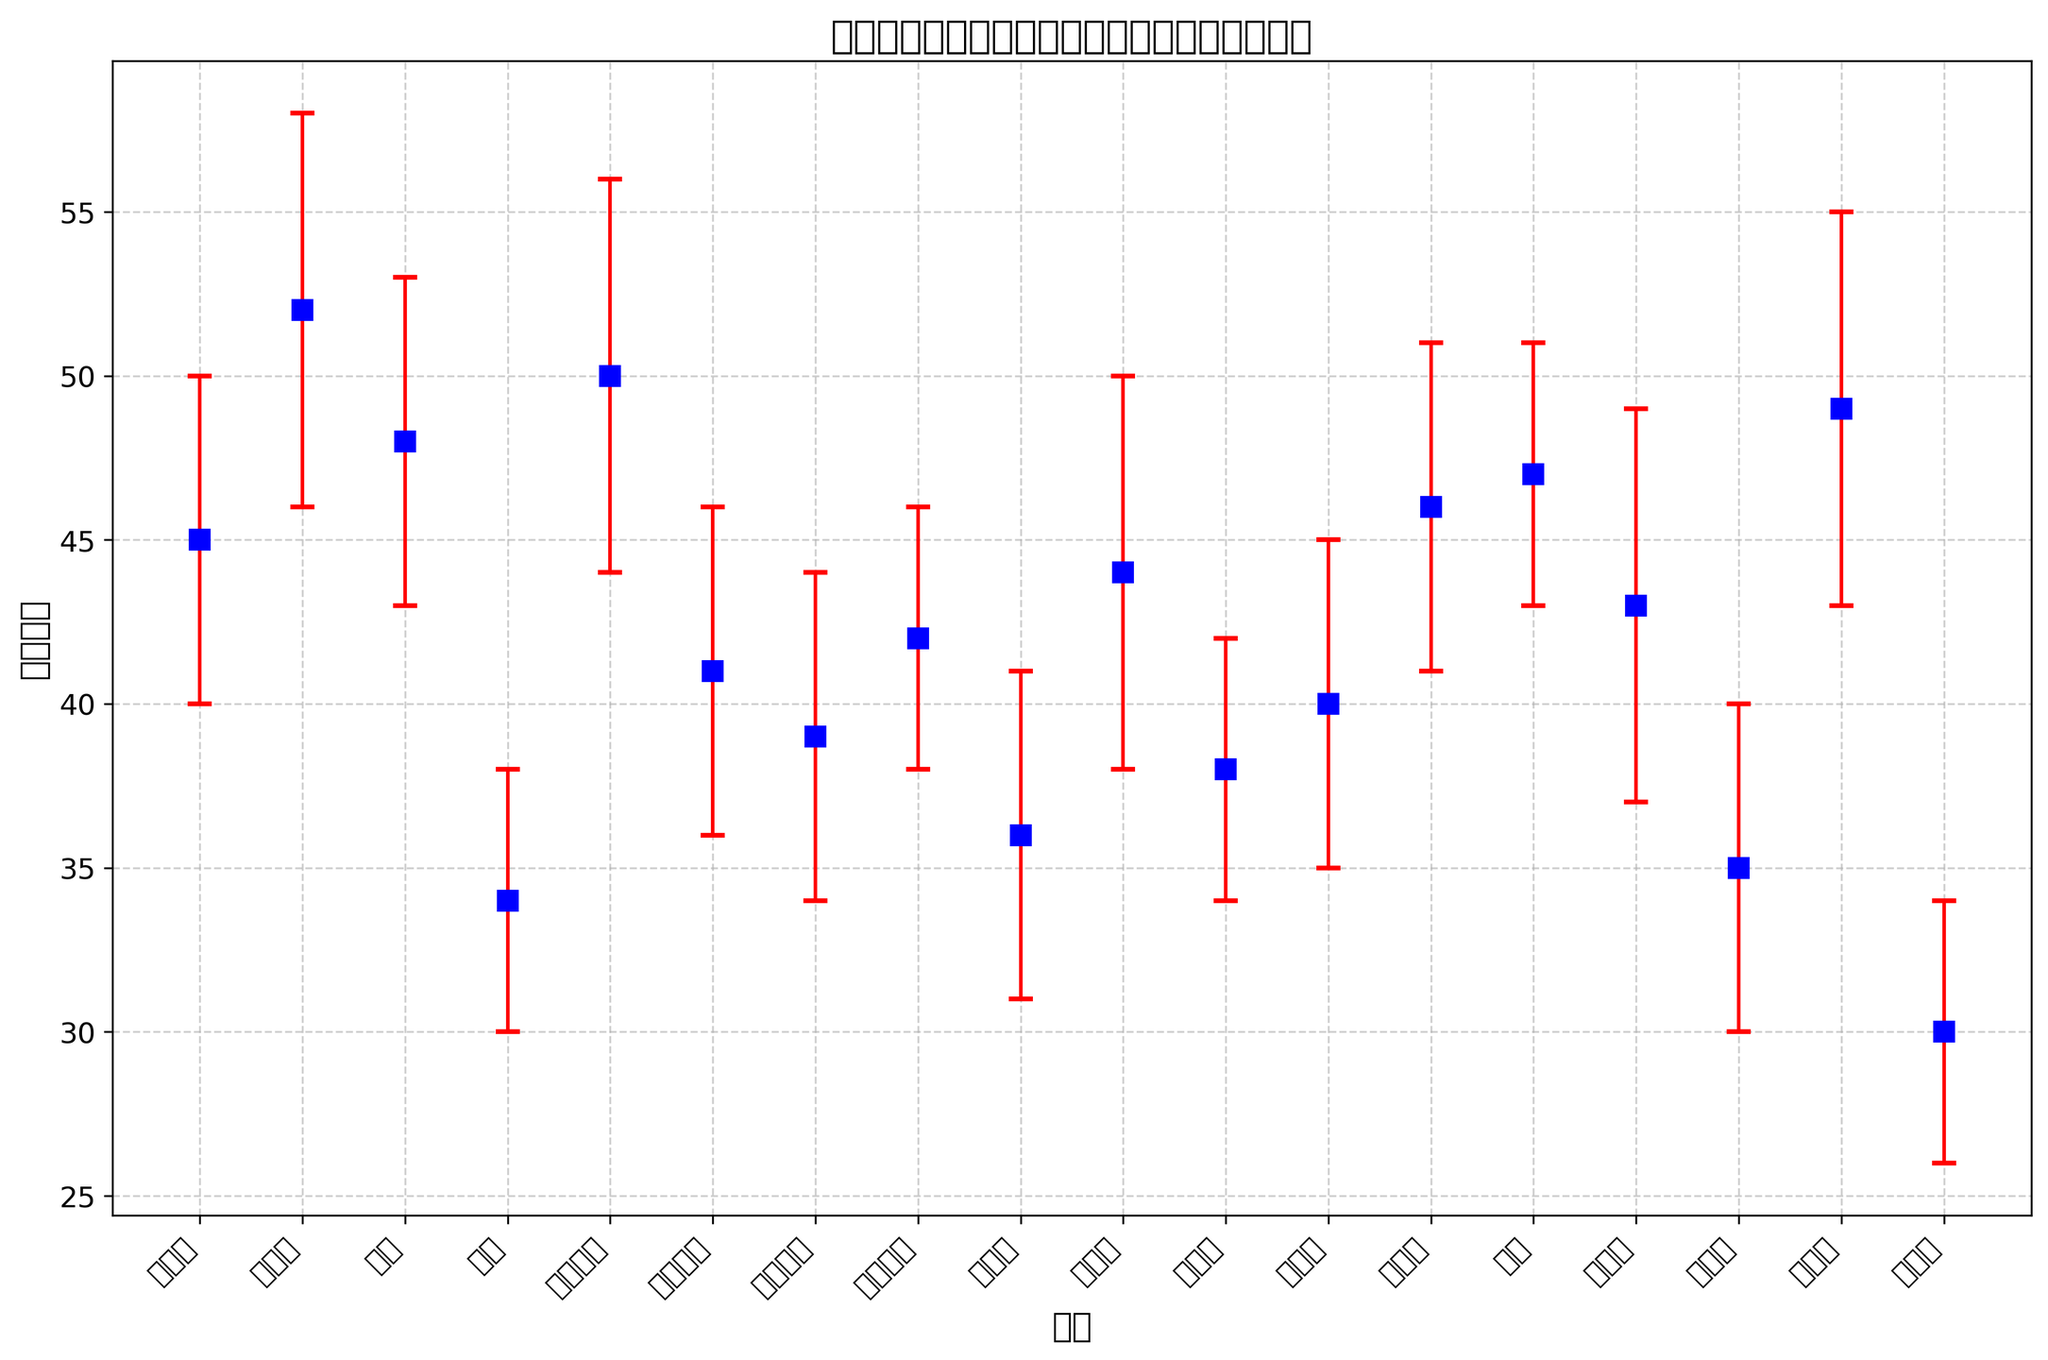Which region has the highest team count? By looking at the plot, we can see which region has the highest data point vertically. The highest team count is shown in Wan Chai District.
Answer: Wan Chai District What is the difference in team counts between the region with the most and the region with the least teams? The region with the most teams is Wan Chai District (52), and the region with the least teams is Islands District (30). The difference is 52 - 30 = 22.
Answer: 22 Which regions have a team count higher than 45? By examining the plot, any data points above the 45 mark on the vertical axis can be identified. These regions are Wan Chai District, Eastern District, Yau Tsim Mong District, Yuen Long District, North District, and Sha Tin District.
Answer: Wan Chai District, Eastern District, Yau Tsim Mong District, Yuen Long District, North District, Sha Tin District What is the average team count across all regions? Sum all the team counts: 45 + 52 + 48 + 34 + 50 + 41 + 39 + 42 + 36 + 44 + 38 + 40 + 46 + 47 + 43 + 35 + 49 + 30 = 709. There are 18 regions. The average is 709 / 18 ≈ 39.39.
Answer: 39.39 Which region has the highest standard deviation in team counts? By observing the plot's error bars, the region with the longest error bar indicates the highest standard deviation. This region is Wan Chai District.
Answer: Wan Chai District What is the sum of team counts for the regions with a team count less than 40? Identify regions with team count < 40: Southern District (34), Kowloon City District (39), Kwun Tong District (36), Tsuen Wan District (38), Islands District (30), Sai Kung District (35). Sum their counts: 34 + 39 + 36 + 38 + 30 + 35 = 212.
Answer: 212 Compare the team count of the North District and the South District. Which one has more teams and by how much? North District has a team count of 47, and South District has a team count of 34. The difference is 47 - 34 = 13, so North District has more teams by 13.
Answer: North District by 13 How does the standard deviation in the Southern District compare to that of the Kwai Tsing District? The standard deviation for the Southern District is 4, and for the Kwai Tsing District, it is 6. Kwai Tsing District has a higher standard deviation by 6 - 4 = 2.
Answer: Kwai Tsing District by 2 What is the total range of team counts across all regions? The maximum team count is in Wan Chai District (52), and the minimum team count is in Islands District (30). The range is 52 - 30 = 22.
Answer: 22 Which regions have a team count within one standard deviation of the average team count? Average team count is 39.39; typical standard deviation across regions is approx. 5. Regions with team counts within 39.39 ± 5 (34.39 - 44.39): Central and Western District, Eastern District, Sham Shui Po District, Kowloon City District, Wong Tai Sin District, Kwai Tsing District, Tsuen Wan District, Tuen Mun District, Yuen Long District, North District, Tai Po District.
Answer: Central and Western District, Eastern District, Sham Shui Po District, Kowloon City District, Wong Tai Sin District, Kwai Tsing District, Tsuen Wan District, Tuen Mun District, Yuen Long District, North District, Tai Po District 